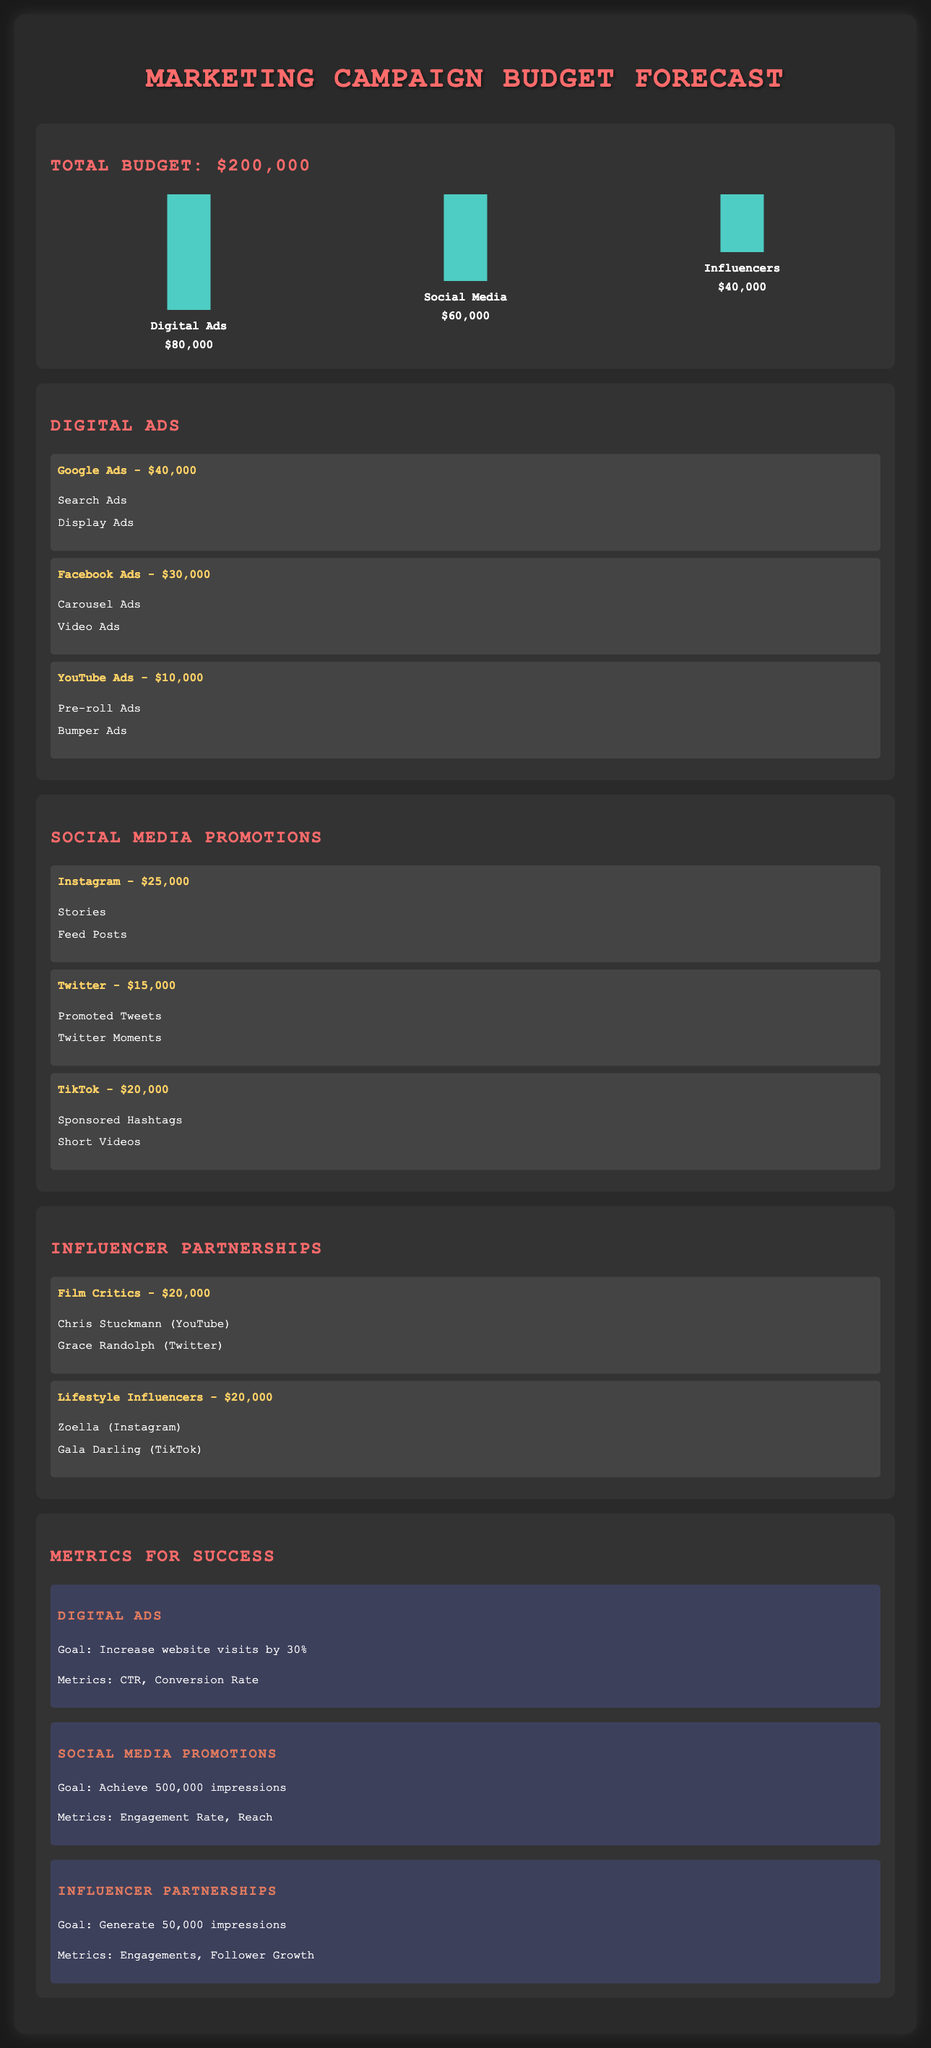What is the total budget for the marketing campaign? The total budget is explicitly mentioned in the document as $200,000.
Answer: $200,000 How much is allocated for digital ads? The document states that $80,000 is allocated for digital ads.
Answer: $80,000 What platforms are included in the digital ads section? The platforms listed under digital ads are Google Ads, Facebook Ads, and YouTube Ads.
Answer: Google Ads, Facebook Ads, YouTube Ads What is the budget for influencer partnerships? The total budget allocated for influencer partnerships is specified as $40,000.
Answer: $40,000 What is the goal for social media promotions? The document mentions that the goal is to achieve 500,000 impressions for social media promotions.
Answer: 500,000 impressions Which influencer partnerships are listed for lifestyle influencers? The lifestyle influencers included are Zoella and Gala Darling.
Answer: Zoella, Gala Darling What is the allocated budget for TikTok promotions? The budget for TikTok promotions is stated as $20,000.
Answer: $20,000 How much is being spent on Instagram? The allocated amount for Instagram promotions is mentioned as $25,000.
Answer: $25,000 What metrics will be evaluated for digital ads? The metrics for digital ads include CTR and Conversion Rate.
Answer: CTR, Conversion Rate 